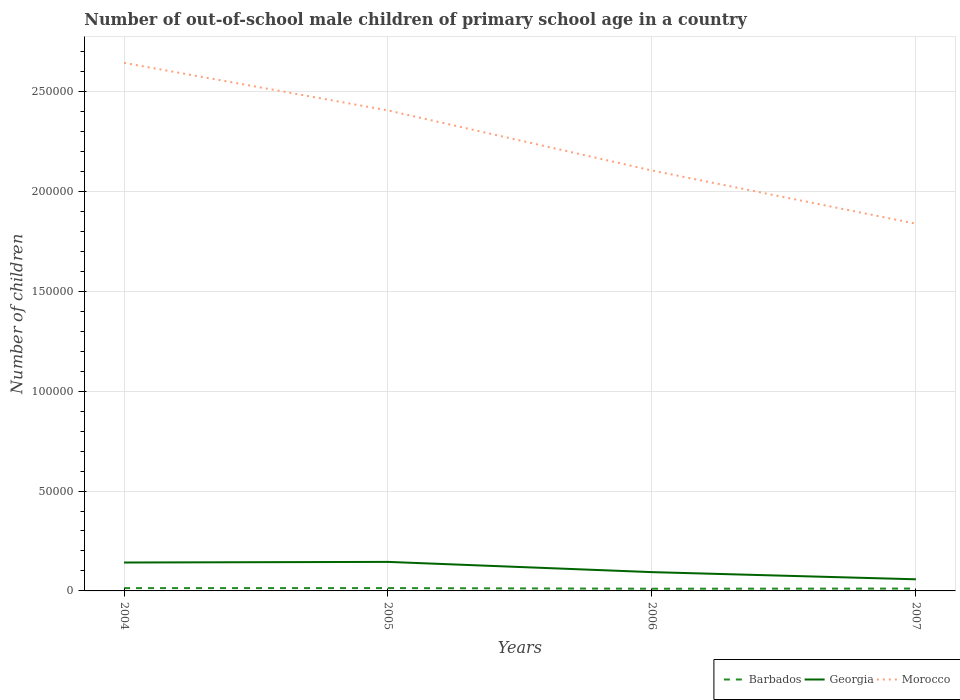Does the line corresponding to Morocco intersect with the line corresponding to Georgia?
Provide a short and direct response. No. Is the number of lines equal to the number of legend labels?
Your answer should be very brief. Yes. Across all years, what is the maximum number of out-of-school male children in Georgia?
Your answer should be compact. 5818. In which year was the number of out-of-school male children in Barbados maximum?
Give a very brief answer. 2006. What is the total number of out-of-school male children in Georgia in the graph?
Make the answer very short. 4809. What is the difference between the highest and the second highest number of out-of-school male children in Morocco?
Offer a terse response. 8.05e+04. What is the difference between the highest and the lowest number of out-of-school male children in Georgia?
Your answer should be very brief. 2. Is the number of out-of-school male children in Georgia strictly greater than the number of out-of-school male children in Barbados over the years?
Provide a succinct answer. No. How many years are there in the graph?
Your answer should be compact. 4. What is the difference between two consecutive major ticks on the Y-axis?
Provide a succinct answer. 5.00e+04. Are the values on the major ticks of Y-axis written in scientific E-notation?
Provide a succinct answer. No. Does the graph contain grids?
Provide a succinct answer. Yes. What is the title of the graph?
Keep it short and to the point. Number of out-of-school male children of primary school age in a country. What is the label or title of the Y-axis?
Provide a short and direct response. Number of children. What is the Number of children of Barbados in 2004?
Offer a very short reply. 1405. What is the Number of children of Georgia in 2004?
Ensure brevity in your answer.  1.42e+04. What is the Number of children in Morocco in 2004?
Offer a very short reply. 2.64e+05. What is the Number of children of Barbados in 2005?
Your answer should be compact. 1420. What is the Number of children of Georgia in 2005?
Offer a very short reply. 1.45e+04. What is the Number of children of Morocco in 2005?
Give a very brief answer. 2.41e+05. What is the Number of children in Barbados in 2006?
Your response must be concise. 1105. What is the Number of children in Georgia in 2006?
Ensure brevity in your answer.  9409. What is the Number of children in Morocco in 2006?
Provide a short and direct response. 2.10e+05. What is the Number of children in Barbados in 2007?
Provide a succinct answer. 1177. What is the Number of children in Georgia in 2007?
Offer a very short reply. 5818. What is the Number of children of Morocco in 2007?
Offer a terse response. 1.84e+05. Across all years, what is the maximum Number of children of Barbados?
Give a very brief answer. 1420. Across all years, what is the maximum Number of children of Georgia?
Ensure brevity in your answer.  1.45e+04. Across all years, what is the maximum Number of children in Morocco?
Provide a succinct answer. 2.64e+05. Across all years, what is the minimum Number of children in Barbados?
Ensure brevity in your answer.  1105. Across all years, what is the minimum Number of children in Georgia?
Ensure brevity in your answer.  5818. Across all years, what is the minimum Number of children in Morocco?
Give a very brief answer. 1.84e+05. What is the total Number of children of Barbados in the graph?
Offer a very short reply. 5107. What is the total Number of children in Georgia in the graph?
Ensure brevity in your answer.  4.40e+04. What is the total Number of children in Morocco in the graph?
Provide a short and direct response. 8.99e+05. What is the difference between the Number of children in Georgia in 2004 and that in 2005?
Make the answer very short. -311. What is the difference between the Number of children of Morocco in 2004 and that in 2005?
Your response must be concise. 2.38e+04. What is the difference between the Number of children in Barbados in 2004 and that in 2006?
Your response must be concise. 300. What is the difference between the Number of children in Georgia in 2004 and that in 2006?
Give a very brief answer. 4809. What is the difference between the Number of children of Morocco in 2004 and that in 2006?
Give a very brief answer. 5.39e+04. What is the difference between the Number of children of Barbados in 2004 and that in 2007?
Give a very brief answer. 228. What is the difference between the Number of children of Georgia in 2004 and that in 2007?
Ensure brevity in your answer.  8400. What is the difference between the Number of children of Morocco in 2004 and that in 2007?
Give a very brief answer. 8.05e+04. What is the difference between the Number of children in Barbados in 2005 and that in 2006?
Give a very brief answer. 315. What is the difference between the Number of children of Georgia in 2005 and that in 2006?
Ensure brevity in your answer.  5120. What is the difference between the Number of children in Morocco in 2005 and that in 2006?
Ensure brevity in your answer.  3.01e+04. What is the difference between the Number of children in Barbados in 2005 and that in 2007?
Ensure brevity in your answer.  243. What is the difference between the Number of children of Georgia in 2005 and that in 2007?
Your answer should be very brief. 8711. What is the difference between the Number of children of Morocco in 2005 and that in 2007?
Give a very brief answer. 5.67e+04. What is the difference between the Number of children in Barbados in 2006 and that in 2007?
Your answer should be very brief. -72. What is the difference between the Number of children in Georgia in 2006 and that in 2007?
Give a very brief answer. 3591. What is the difference between the Number of children in Morocco in 2006 and that in 2007?
Offer a terse response. 2.66e+04. What is the difference between the Number of children in Barbados in 2004 and the Number of children in Georgia in 2005?
Ensure brevity in your answer.  -1.31e+04. What is the difference between the Number of children of Barbados in 2004 and the Number of children of Morocco in 2005?
Ensure brevity in your answer.  -2.39e+05. What is the difference between the Number of children in Georgia in 2004 and the Number of children in Morocco in 2005?
Your answer should be compact. -2.26e+05. What is the difference between the Number of children of Barbados in 2004 and the Number of children of Georgia in 2006?
Provide a short and direct response. -8004. What is the difference between the Number of children of Barbados in 2004 and the Number of children of Morocco in 2006?
Your response must be concise. -2.09e+05. What is the difference between the Number of children of Georgia in 2004 and the Number of children of Morocco in 2006?
Give a very brief answer. -1.96e+05. What is the difference between the Number of children in Barbados in 2004 and the Number of children in Georgia in 2007?
Provide a succinct answer. -4413. What is the difference between the Number of children of Barbados in 2004 and the Number of children of Morocco in 2007?
Offer a very short reply. -1.82e+05. What is the difference between the Number of children in Georgia in 2004 and the Number of children in Morocco in 2007?
Offer a terse response. -1.70e+05. What is the difference between the Number of children in Barbados in 2005 and the Number of children in Georgia in 2006?
Make the answer very short. -7989. What is the difference between the Number of children in Barbados in 2005 and the Number of children in Morocco in 2006?
Offer a terse response. -2.09e+05. What is the difference between the Number of children in Georgia in 2005 and the Number of children in Morocco in 2006?
Make the answer very short. -1.96e+05. What is the difference between the Number of children of Barbados in 2005 and the Number of children of Georgia in 2007?
Offer a very short reply. -4398. What is the difference between the Number of children of Barbados in 2005 and the Number of children of Morocco in 2007?
Offer a terse response. -1.82e+05. What is the difference between the Number of children of Georgia in 2005 and the Number of children of Morocco in 2007?
Ensure brevity in your answer.  -1.69e+05. What is the difference between the Number of children of Barbados in 2006 and the Number of children of Georgia in 2007?
Offer a terse response. -4713. What is the difference between the Number of children in Barbados in 2006 and the Number of children in Morocco in 2007?
Your answer should be very brief. -1.83e+05. What is the difference between the Number of children of Georgia in 2006 and the Number of children of Morocco in 2007?
Give a very brief answer. -1.74e+05. What is the average Number of children in Barbados per year?
Keep it short and to the point. 1276.75. What is the average Number of children in Georgia per year?
Make the answer very short. 1.10e+04. What is the average Number of children of Morocco per year?
Offer a very short reply. 2.25e+05. In the year 2004, what is the difference between the Number of children of Barbados and Number of children of Georgia?
Offer a terse response. -1.28e+04. In the year 2004, what is the difference between the Number of children of Barbados and Number of children of Morocco?
Offer a terse response. -2.63e+05. In the year 2004, what is the difference between the Number of children in Georgia and Number of children in Morocco?
Your answer should be very brief. -2.50e+05. In the year 2005, what is the difference between the Number of children in Barbados and Number of children in Georgia?
Give a very brief answer. -1.31e+04. In the year 2005, what is the difference between the Number of children of Barbados and Number of children of Morocco?
Your response must be concise. -2.39e+05. In the year 2005, what is the difference between the Number of children in Georgia and Number of children in Morocco?
Offer a very short reply. -2.26e+05. In the year 2006, what is the difference between the Number of children of Barbados and Number of children of Georgia?
Your answer should be very brief. -8304. In the year 2006, what is the difference between the Number of children in Barbados and Number of children in Morocco?
Your response must be concise. -2.09e+05. In the year 2006, what is the difference between the Number of children in Georgia and Number of children in Morocco?
Your answer should be very brief. -2.01e+05. In the year 2007, what is the difference between the Number of children in Barbados and Number of children in Georgia?
Provide a succinct answer. -4641. In the year 2007, what is the difference between the Number of children in Barbados and Number of children in Morocco?
Offer a terse response. -1.83e+05. In the year 2007, what is the difference between the Number of children of Georgia and Number of children of Morocco?
Provide a succinct answer. -1.78e+05. What is the ratio of the Number of children in Georgia in 2004 to that in 2005?
Provide a short and direct response. 0.98. What is the ratio of the Number of children in Morocco in 2004 to that in 2005?
Offer a very short reply. 1.1. What is the ratio of the Number of children of Barbados in 2004 to that in 2006?
Make the answer very short. 1.27. What is the ratio of the Number of children of Georgia in 2004 to that in 2006?
Offer a very short reply. 1.51. What is the ratio of the Number of children in Morocco in 2004 to that in 2006?
Make the answer very short. 1.26. What is the ratio of the Number of children of Barbados in 2004 to that in 2007?
Your answer should be compact. 1.19. What is the ratio of the Number of children in Georgia in 2004 to that in 2007?
Offer a very short reply. 2.44. What is the ratio of the Number of children in Morocco in 2004 to that in 2007?
Make the answer very short. 1.44. What is the ratio of the Number of children of Barbados in 2005 to that in 2006?
Provide a succinct answer. 1.29. What is the ratio of the Number of children of Georgia in 2005 to that in 2006?
Give a very brief answer. 1.54. What is the ratio of the Number of children in Morocco in 2005 to that in 2006?
Give a very brief answer. 1.14. What is the ratio of the Number of children of Barbados in 2005 to that in 2007?
Keep it short and to the point. 1.21. What is the ratio of the Number of children in Georgia in 2005 to that in 2007?
Offer a terse response. 2.5. What is the ratio of the Number of children of Morocco in 2005 to that in 2007?
Provide a succinct answer. 1.31. What is the ratio of the Number of children in Barbados in 2006 to that in 2007?
Ensure brevity in your answer.  0.94. What is the ratio of the Number of children of Georgia in 2006 to that in 2007?
Your response must be concise. 1.62. What is the ratio of the Number of children of Morocco in 2006 to that in 2007?
Ensure brevity in your answer.  1.14. What is the difference between the highest and the second highest Number of children in Georgia?
Your answer should be very brief. 311. What is the difference between the highest and the second highest Number of children in Morocco?
Provide a succinct answer. 2.38e+04. What is the difference between the highest and the lowest Number of children in Barbados?
Your response must be concise. 315. What is the difference between the highest and the lowest Number of children in Georgia?
Your answer should be compact. 8711. What is the difference between the highest and the lowest Number of children of Morocco?
Your answer should be compact. 8.05e+04. 